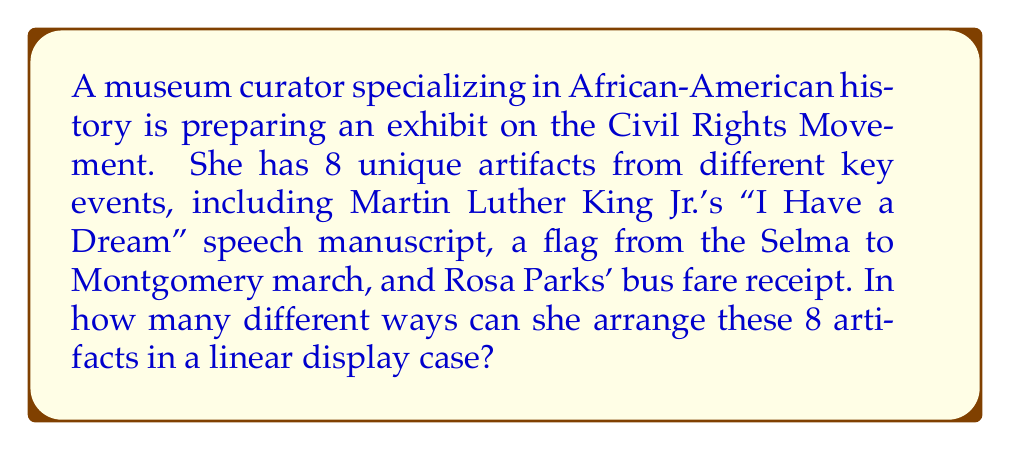Teach me how to tackle this problem. To solve this problem, we need to consider the concept of permutations. A permutation is an arrangement of objects where order matters.

In this case:
1. We have 8 unique artifacts.
2. All artifacts must be used in the arrangement.
3. The order of placement matters (linear display case).

This scenario fits the definition of a permutation without repetition. The formula for such permutations is:

$$P(n) = n!$$

Where $n$ is the number of unique objects.

For our problem:
$$P(8) = 8!$$

To calculate this:
$$8! = 8 \times 7 \times 6 \times 5 \times 4 \times 3 \times 2 \times 1 = 40,320$$

This result reflects the number of ways to arrange 8 unique objects in a linear order. Each arrangement represents a different way the curator could set up the exhibit, potentially emphasizing different aspects of the Civil Rights Movement's chronology or thematic connections.
Answer: $$40,320$$ 